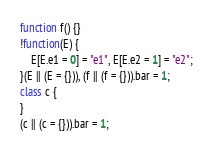Convert code to text. <code><loc_0><loc_0><loc_500><loc_500><_JavaScript_>function f() {}
!function(E) {
    E[E.e1 = 0] = "e1", E[E.e2 = 1] = "e2";
}(E || (E = {})), (f || (f = {})).bar = 1;
class c {
}
(c || (c = {})).bar = 1;
</code> 